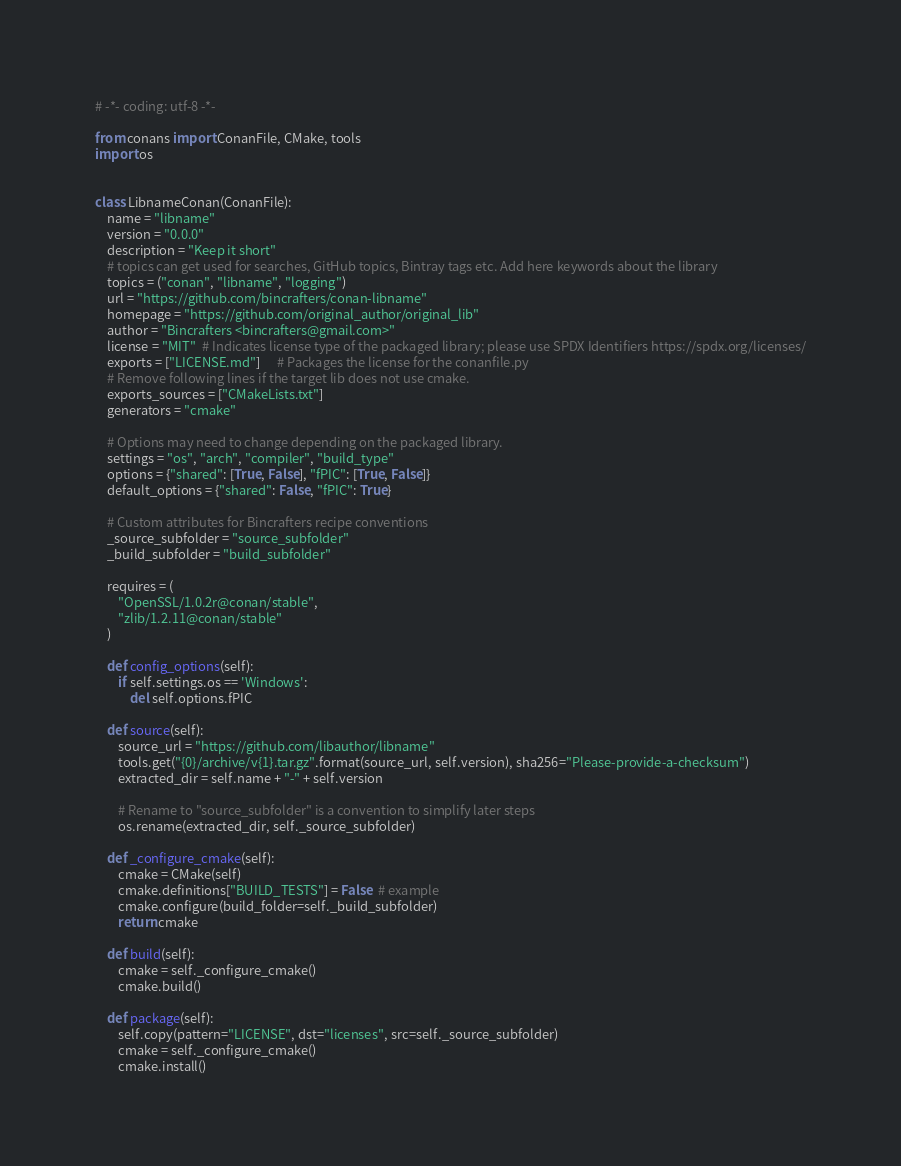Convert code to text. <code><loc_0><loc_0><loc_500><loc_500><_Python_># -*- coding: utf-8 -*-

from conans import ConanFile, CMake, tools
import os


class LibnameConan(ConanFile):
    name = "libname"
    version = "0.0.0"
    description = "Keep it short"
    # topics can get used for searches, GitHub topics, Bintray tags etc. Add here keywords about the library
    topics = ("conan", "libname", "logging")
    url = "https://github.com/bincrafters/conan-libname"
    homepage = "https://github.com/original_author/original_lib"
    author = "Bincrafters <bincrafters@gmail.com>"
    license = "MIT"  # Indicates license type of the packaged library; please use SPDX Identifiers https://spdx.org/licenses/
    exports = ["LICENSE.md"]      # Packages the license for the conanfile.py
    # Remove following lines if the target lib does not use cmake.
    exports_sources = ["CMakeLists.txt"]
    generators = "cmake"

    # Options may need to change depending on the packaged library.
    settings = "os", "arch", "compiler", "build_type"
    options = {"shared": [True, False], "fPIC": [True, False]}
    default_options = {"shared": False, "fPIC": True}

    # Custom attributes for Bincrafters recipe conventions
    _source_subfolder = "source_subfolder"
    _build_subfolder = "build_subfolder"

    requires = (
        "OpenSSL/1.0.2r@conan/stable",
        "zlib/1.2.11@conan/stable"
    )

    def config_options(self):
        if self.settings.os == 'Windows':
            del self.options.fPIC

    def source(self):
        source_url = "https://github.com/libauthor/libname"
        tools.get("{0}/archive/v{1}.tar.gz".format(source_url, self.version), sha256="Please-provide-a-checksum")
        extracted_dir = self.name + "-" + self.version

        # Rename to "source_subfolder" is a convention to simplify later steps
        os.rename(extracted_dir, self._source_subfolder)

    def _configure_cmake(self):
        cmake = CMake(self)
        cmake.definitions["BUILD_TESTS"] = False  # example
        cmake.configure(build_folder=self._build_subfolder)
        return cmake

    def build(self):
        cmake = self._configure_cmake()
        cmake.build()

    def package(self):
        self.copy(pattern="LICENSE", dst="licenses", src=self._source_subfolder)
        cmake = self._configure_cmake()
        cmake.install()</code> 